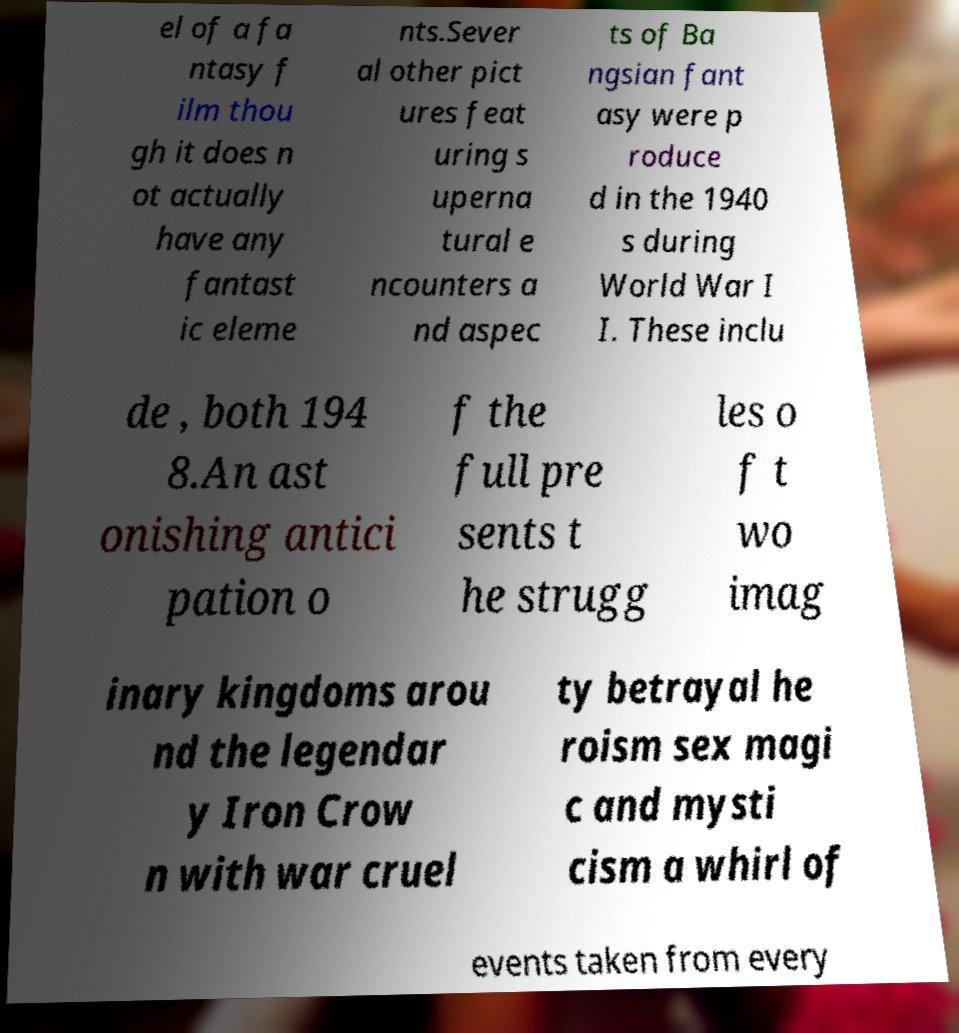I need the written content from this picture converted into text. Can you do that? el of a fa ntasy f ilm thou gh it does n ot actually have any fantast ic eleme nts.Sever al other pict ures feat uring s uperna tural e ncounters a nd aspec ts of Ba ngsian fant asy were p roduce d in the 1940 s during World War I I. These inclu de , both 194 8.An ast onishing antici pation o f the full pre sents t he strugg les o f t wo imag inary kingdoms arou nd the legendar y Iron Crow n with war cruel ty betrayal he roism sex magi c and mysti cism a whirl of events taken from every 